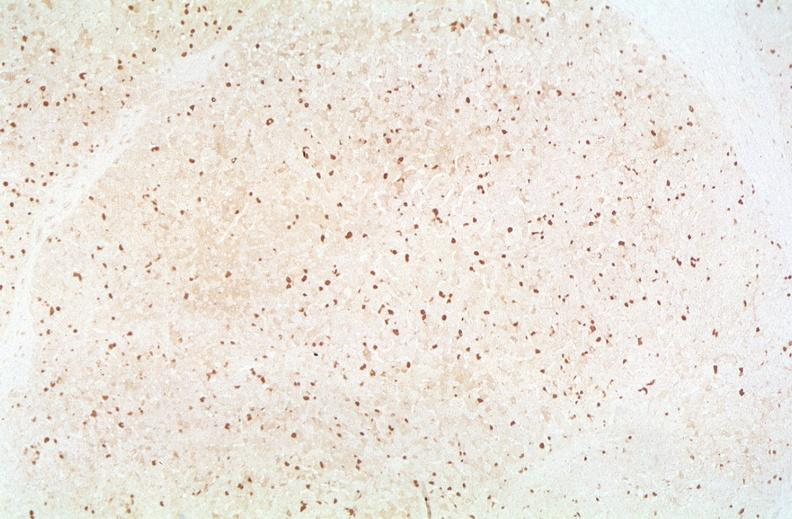does single metastatic appearing lesion show hepatitis b virus, hbv surface antigen immunohistochemistry?
Answer the question using a single word or phrase. No 